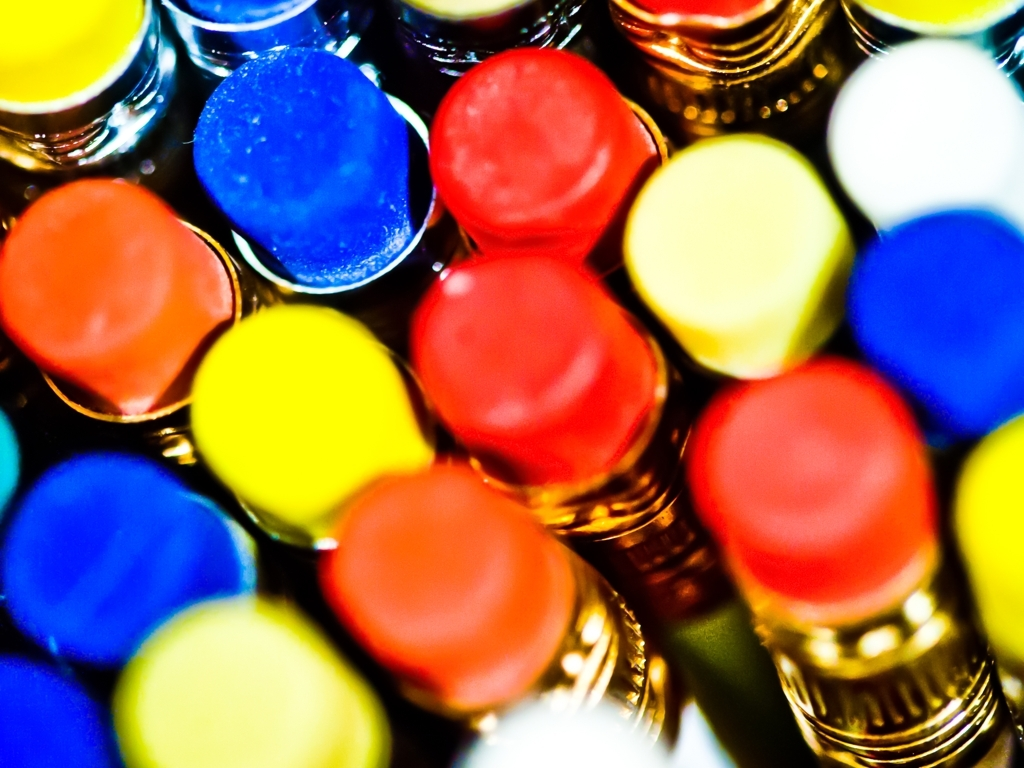Is the image properly focused? The image appears to be intentionally using a shallow depth of field, with only a small area in clear focus while the rest is blurred, which is a common artistic technique in photography to draw attention to a particular element of the image. 